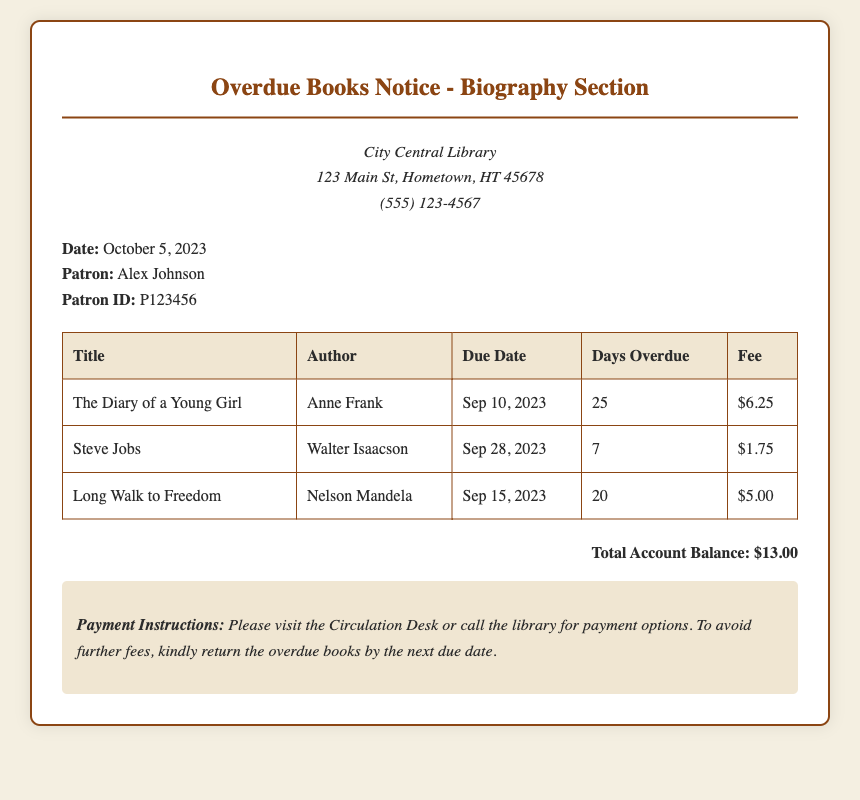What is the total account balance? The total account balance is listed at the bottom of the document, summing up the fees for all overdue books.
Answer: $13.00 Who is the patron? The document provides the name of the patron in the patron information section.
Answer: Alex Johnson What is the due date for "The Diary of a Young Girl"? The due date is specified in the table under the due date column for this particular book title.
Answer: Sep 10, 2023 How many days is "Steve Jobs" overdue? The document mentions the number of days overdue next to the title in the table provided.
Answer: 7 Which book has the highest fee? The fees for each book are shown in the table, and this question asks for the title associated with the highest amount.
Answer: The Diary of a Young Girl What is the fee for "Long Walk to Freedom"? The fee is listed in the same row as the title in the table, specifying the cost for this book.
Answer: $5.00 When was this notice issued? The date is provided in the patron information section of the document.
Answer: October 5, 2023 How many overdue books are listed? The number of books is determined by counting the rows present in the table.
Answer: 3 What does the library suggest to avoid further fees? This is regarding the instructions provided at the end of the notice regarding returning books.
Answer: Return overdue books 